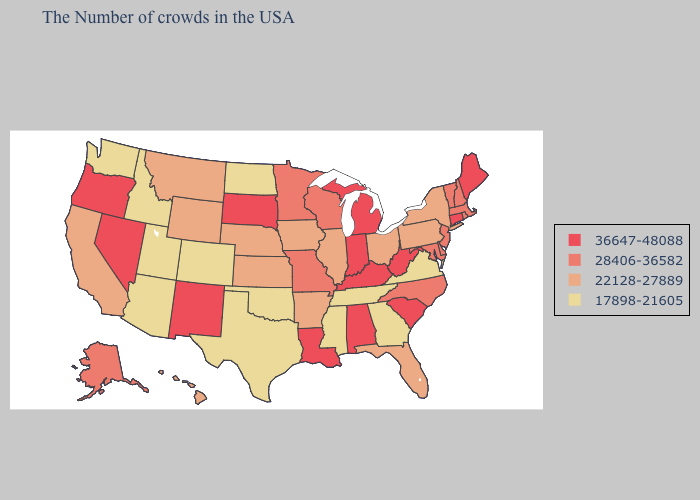Among the states that border Montana , which have the lowest value?
Concise answer only. North Dakota, Idaho. Among the states that border Louisiana , does Arkansas have the lowest value?
Write a very short answer. No. Name the states that have a value in the range 22128-27889?
Keep it brief. New York, Pennsylvania, Ohio, Florida, Illinois, Arkansas, Iowa, Kansas, Nebraska, Wyoming, Montana, California, Hawaii. Name the states that have a value in the range 28406-36582?
Write a very short answer. Massachusetts, Rhode Island, New Hampshire, Vermont, New Jersey, Delaware, Maryland, North Carolina, Wisconsin, Missouri, Minnesota, Alaska. Which states have the lowest value in the South?
Quick response, please. Virginia, Georgia, Tennessee, Mississippi, Oklahoma, Texas. Name the states that have a value in the range 22128-27889?
Concise answer only. New York, Pennsylvania, Ohio, Florida, Illinois, Arkansas, Iowa, Kansas, Nebraska, Wyoming, Montana, California, Hawaii. What is the value of New Hampshire?
Keep it brief. 28406-36582. Does the first symbol in the legend represent the smallest category?
Short answer required. No. What is the value of Wyoming?
Quick response, please. 22128-27889. Does Montana have the highest value in the USA?
Short answer required. No. What is the highest value in states that border Nebraska?
Quick response, please. 36647-48088. Name the states that have a value in the range 17898-21605?
Quick response, please. Virginia, Georgia, Tennessee, Mississippi, Oklahoma, Texas, North Dakota, Colorado, Utah, Arizona, Idaho, Washington. What is the value of New Jersey?
Quick response, please. 28406-36582. Does Arizona have a lower value than New Jersey?
Give a very brief answer. Yes. Name the states that have a value in the range 28406-36582?
Be succinct. Massachusetts, Rhode Island, New Hampshire, Vermont, New Jersey, Delaware, Maryland, North Carolina, Wisconsin, Missouri, Minnesota, Alaska. 